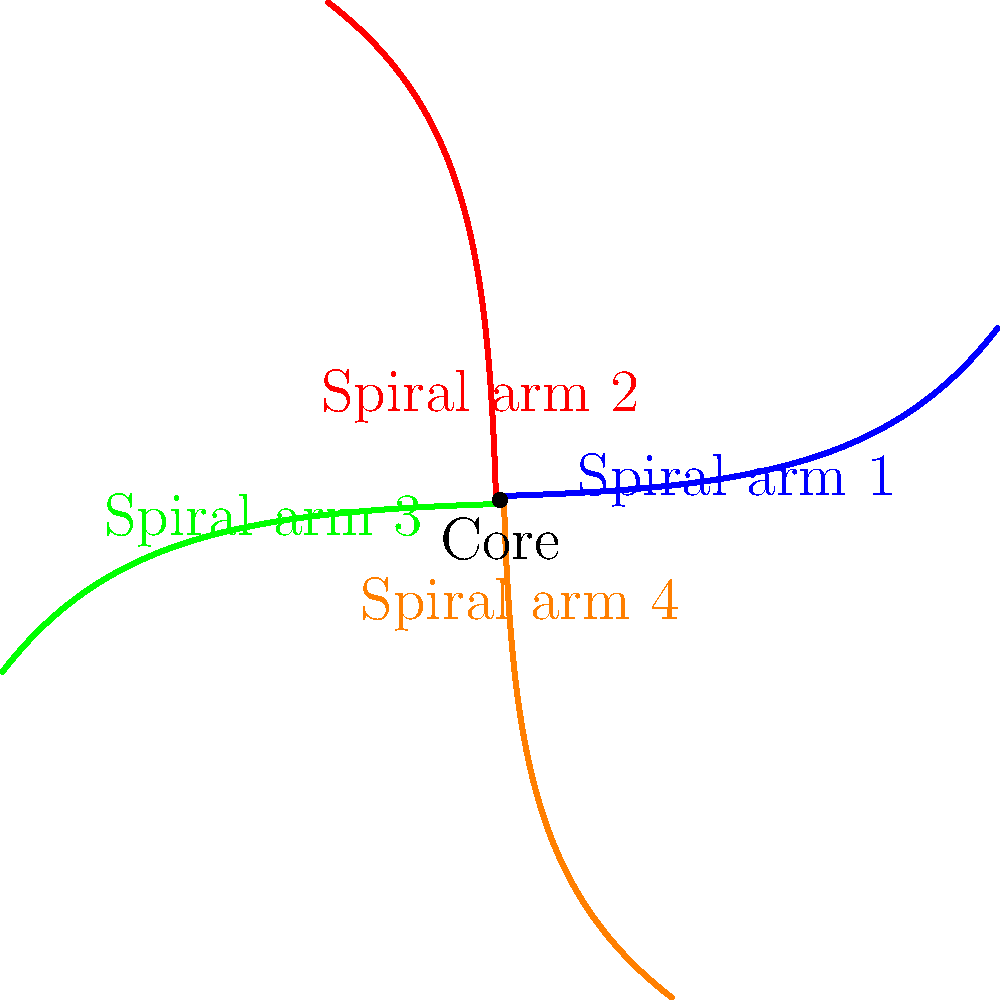In the diagram of a spiral galaxy, which component would likely contain the highest concentration of young, massive stars that could potentially produce interesting audio phenomena for recording? To answer this question, let's consider the structure of a spiral galaxy and the characteristics of its components:

1. The core (center) of the galaxy:
   - Contains mostly older stars
   - Has less gas and dust for new star formation

2. The spiral arms:
   - Rich in gas and dust
   - Sites of active star formation
   - Contain many young, massive stars

3. Young, massive stars:
   - Have shorter lifespans than smaller stars
   - Produce intense stellar winds and radiation
   - Can create interesting astronomical phenomena like supernovae

4. Audio phenomena in space:
   - While sound doesn't travel in the vacuum of space, many astronomical events produce radio waves and other electromagnetic radiation
   - These signals can be converted into audio for study and analysis

5. Relevance to audio recording:
   - The spiral arms, with their concentration of young, massive stars, are more likely to produce dynamic and diverse astronomical phenomena
   - These phenomena can generate a wide range of signals that could be interesting for audio recording and analysis

Therefore, the spiral arms of the galaxy would likely contain the highest concentration of young, massive stars that could potentially produce interesting audio phenomena for recording.
Answer: Spiral arms 